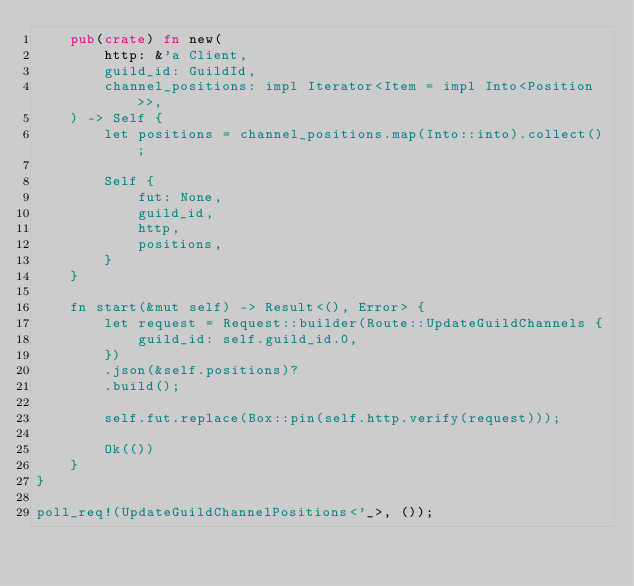<code> <loc_0><loc_0><loc_500><loc_500><_Rust_>    pub(crate) fn new(
        http: &'a Client,
        guild_id: GuildId,
        channel_positions: impl Iterator<Item = impl Into<Position>>,
    ) -> Self {
        let positions = channel_positions.map(Into::into).collect();

        Self {
            fut: None,
            guild_id,
            http,
            positions,
        }
    }

    fn start(&mut self) -> Result<(), Error> {
        let request = Request::builder(Route::UpdateGuildChannels {
            guild_id: self.guild_id.0,
        })
        .json(&self.positions)?
        .build();

        self.fut.replace(Box::pin(self.http.verify(request)));

        Ok(())
    }
}

poll_req!(UpdateGuildChannelPositions<'_>, ());
</code> 